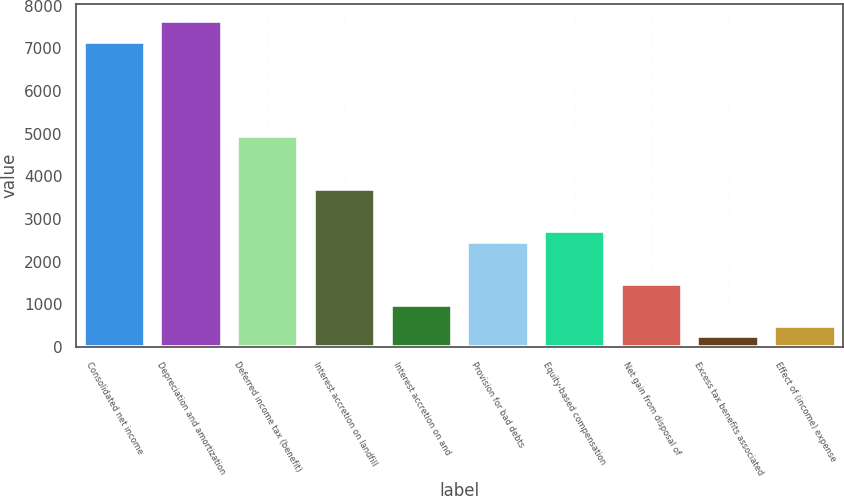Convert chart. <chart><loc_0><loc_0><loc_500><loc_500><bar_chart><fcel>Consolidated net income<fcel>Depreciation and amortization<fcel>Deferred income tax (benefit)<fcel>Interest accretion on landfill<fcel>Interest accretion on and<fcel>Provision for bad debts<fcel>Equity-based compensation<fcel>Net gain from disposal of<fcel>Excess tax benefits associated<fcel>Effect of (income) expense<nl><fcel>7158.2<fcel>7651.8<fcel>4937<fcel>3703<fcel>988.2<fcel>2469<fcel>2715.8<fcel>1481.8<fcel>247.8<fcel>494.6<nl></chart> 